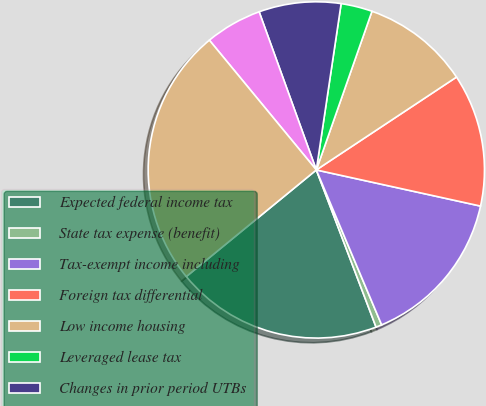<chart> <loc_0><loc_0><loc_500><loc_500><pie_chart><fcel>Expected federal income tax<fcel>State tax expense (benefit)<fcel>Tax-exempt income including<fcel>Foreign tax differential<fcel>Low income housing<fcel>Leveraged lease tax<fcel>Changes in prior period UTBs<fcel>Other<fcel>Total income tax expense<nl><fcel>19.85%<fcel>0.57%<fcel>15.2%<fcel>12.76%<fcel>10.32%<fcel>3.01%<fcel>7.88%<fcel>5.45%<fcel>24.96%<nl></chart> 